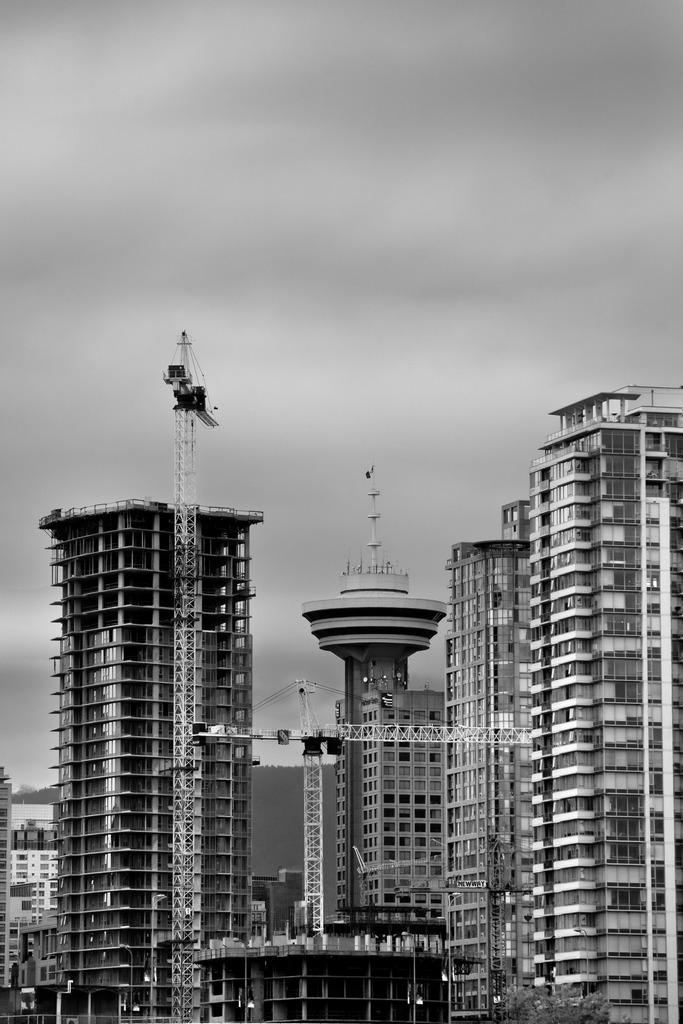What structures are present in the image? There are towers in the image. What can be seen at the top of the image? The sky is visible at the top of the image. What type of drum is being played in the image? There is no drum present in the image; it only features towers and the sky. Does the existence of the towers in the image prove the existence of a parallel universe? The presence of towers in the image does not provide any information about the existence of a parallel universe. 